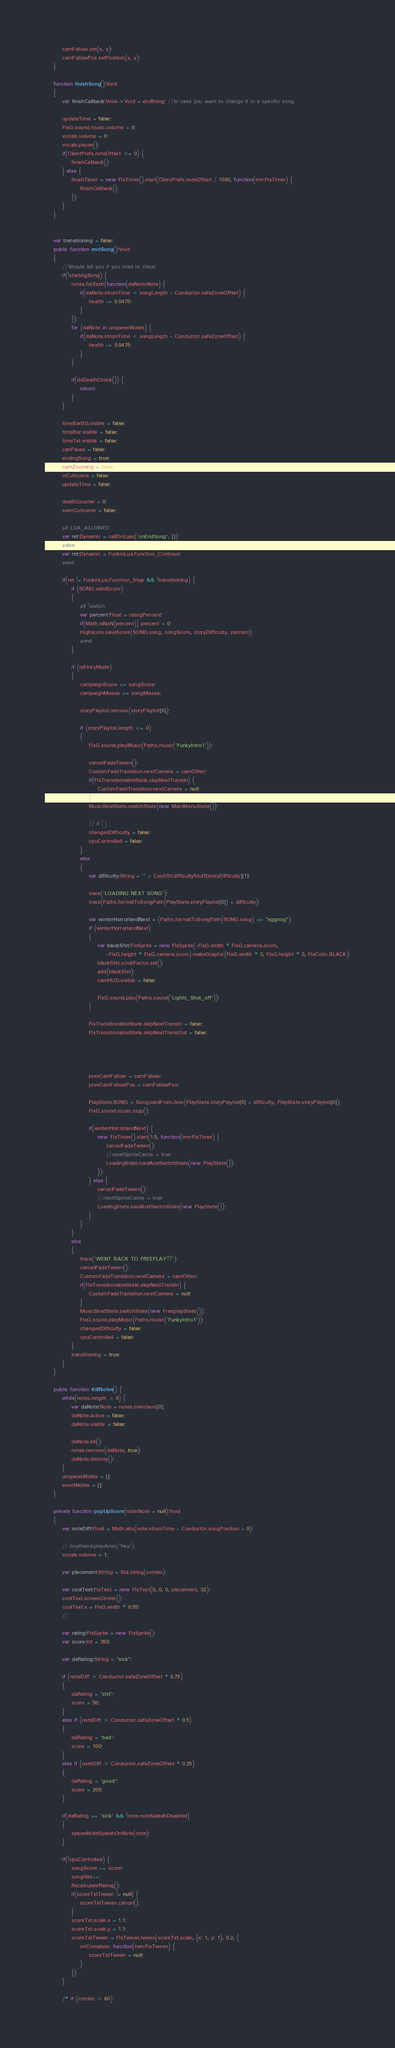<code> <loc_0><loc_0><loc_500><loc_500><_Haxe_>		camFollow.set(x, y);
		camFollowPos.setPosition(x, y);
	}

	function finishSong():Void
	{
		var finishCallback:Void->Void = endSong; //In case you want to change it in a specific song.

		updateTime = false;
		FlxG.sound.music.volume = 0;
		vocals.volume = 0;
		vocals.pause();
		if(ClientPrefs.noteOffset <= 0) {
			finishCallback();
		} else {
			finishTimer = new FlxTimer().start(ClientPrefs.noteOffset / 1000, function(tmr:FlxTimer) {
				finishCallback();
			});
		}
	}


	var transitioning = false;
	public function endSong():Void
	{
		//Should kill you if you tried to cheat
		if(!startingSong) {
			notes.forEach(function(daNote:Note) {
				if(daNote.strumTime < songLength - Conductor.safeZoneOffset) {
					health -= 0.0475;
				}
			});
			for (daNote in unspawnNotes) {
				if(daNote.strumTime < songLength - Conductor.safeZoneOffset) {
					health -= 0.0475;
				}
			}

			if(doDeathCheck()) {
				return;
			}
		}
		
		timeBarBG.visible = false;
		timeBar.visible = false;
		timeTxt.visible = false;
		canPause = false;
		endingSong = true;
		camZooming = false;
		inCutscene = false;
		updateTime = false;

		deathCounter = 0;
		seenCutscene = false;
		
		#if LUA_ALLOWED
		var ret:Dynamic = callOnLuas('onEndSong', []);
		#else
		var ret:Dynamic = FunkinLua.Function_Continue;
		#end

		if(ret != FunkinLua.Function_Stop && !transitioning) {
			if (SONG.validScore)
			{
				#if !switch
				var percent:Float = ratingPercent;
				if(Math.isNaN(percent)) percent = 0;
				Highscore.saveScore(SONG.song, songScore, storyDifficulty, percent);
				#end
			}

			if (isStoryMode)
			{
				campaignScore += songScore;
				campaignMisses += songMisses;

				storyPlaylist.remove(storyPlaylist[0]);

				if (storyPlaylist.length <= 0)
				{
					FlxG.sound.playMusic(Paths.music('FunkyIntro1'));

					cancelFadeTween();
					CustomFadeTransition.nextCamera = camOther;
					if(FlxTransitionableState.skipNextTransIn) {
						CustomFadeTransition.nextCamera = null;
					}
					MusicBeatState.switchState(new MainMenuState());

					// if ()
					changedDifficulty = false;
					cpuControlled = false;
				}
				else
				{
					var difficulty:String = '' + CoolUtil.difficultyStuff[storyDifficulty][1];

					trace('LOADING NEXT SONG');
					trace(Paths.formatToSongPath(PlayState.storyPlaylist[0]) + difficulty);

					var winterHorrorlandNext = (Paths.formatToSongPath(SONG.song) == "eggnog");
					if (winterHorrorlandNext)
					{
						var blackShit:FlxSprite = new FlxSprite(-FlxG.width * FlxG.camera.zoom,
							-FlxG.height * FlxG.camera.zoom).makeGraphic(FlxG.width * 3, FlxG.height * 3, FlxColor.BLACK);
						blackShit.scrollFactor.set();
						add(blackShit);
						camHUD.visible = false;

						FlxG.sound.play(Paths.sound('Lights_Shut_off'));
					}

					FlxTransitionableState.skipNextTransIn = false;
					FlxTransitionableState.skipNextTransOut = false;
					


					
					prevCamFollow = camFollow;
					prevCamFollowPos = camFollowPos;

					PlayState.SONG = Song.loadFromJson(PlayState.storyPlaylist[0] + difficulty, PlayState.storyPlaylist[0]);
					FlxG.sound.music.stop();

					if(winterHorrorlandNext) {
						new FlxTimer().start(1.5, function(tmr:FlxTimer) {
							cancelFadeTween();
							//resetSpriteCache = true;
							LoadingState.loadAndSwitchState(new PlayState());
						});
					} else {
						cancelFadeTween();
						//resetSpriteCache = true;
						LoadingState.loadAndSwitchState(new PlayState());
					}
				}
			}
			else
			{
				trace('WENT BACK TO FREEPLAY??');
				cancelFadeTween();
				CustomFadeTransition.nextCamera = camOther;
				if(FlxTransitionableState.skipNextTransIn) {
					CustomFadeTransition.nextCamera = null;
				}
				MusicBeatState.switchState(new FreeplayState());
				FlxG.sound.playMusic(Paths.music('FunkyIntro1'));
				changedDifficulty = false;
				cpuControlled = false;
			}
			transitioning = true;
		}
	}

	public function KillNotes() {
		while(notes.length > 0) {
			var daNote:Note = notes.members[0];
			daNote.active = false;
			daNote.visible = false;

			daNote.kill();
			notes.remove(daNote, true);
			daNote.destroy();
		}
		unspawnNotes = [];
		eventNotes = [];
	}

	private function popUpScore(note:Note = null):Void
	{
		var noteDiff:Float = Math.abs(note.strumTime - Conductor.songPosition + 8); 

		// boyfriend.playAnim('hey');
		vocals.volume = 1;

		var placement:String = Std.string(combo);

		var coolText:FlxText = new FlxText(0, 0, 0, placement, 32);
		coolText.screenCenter();
		coolText.x = FlxG.width * 0.55;
		//

		var rating:FlxSprite = new FlxSprite();
		var score:Int = 350;

		var daRating:String = "sick";

		if (noteDiff > Conductor.safeZoneOffset * 0.75)
		{
			daRating = 'shit';
			score = 50;
		}
		else if (noteDiff > Conductor.safeZoneOffset * 0.5)
		{
			daRating = 'bad';
			score = 100;
		}
		else if (noteDiff > Conductor.safeZoneOffset * 0.25)
		{
			daRating = 'good';
			score = 200;
		}

		if(daRating == 'sick' && !note.noteSplashDisabled)
		{
			spawnNoteSplashOnNote(note);
		}

		if(!cpuControlled) {
			songScore += score;
			songHits++;
			RecalculateRating();
			if(scoreTxtTween != null) {
				scoreTxtTween.cancel();
			}
			scoreTxt.scale.x = 1.1;
			scoreTxt.scale.y = 1.1;
			scoreTxtTween = FlxTween.tween(scoreTxt.scale, {x: 1, y: 1}, 0.2, {
				onComplete: function(twn:FlxTween) {
					scoreTxtTween = null;
				}
			});
		}

		/* if (combo > 60)</code> 